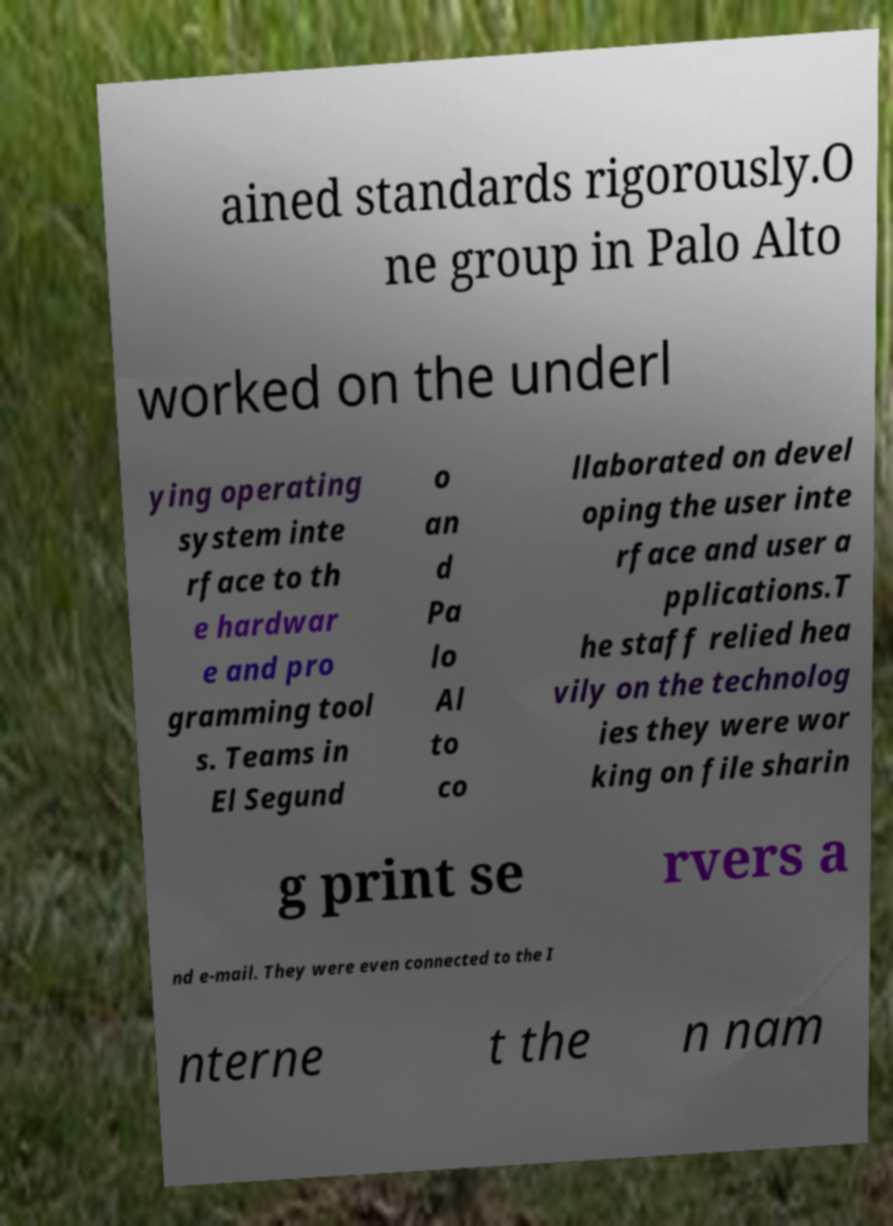I need the written content from this picture converted into text. Can you do that? ained standards rigorously.O ne group in Palo Alto worked on the underl ying operating system inte rface to th e hardwar e and pro gramming tool s. Teams in El Segund o an d Pa lo Al to co llaborated on devel oping the user inte rface and user a pplications.T he staff relied hea vily on the technolog ies they were wor king on file sharin g print se rvers a nd e-mail. They were even connected to the I nterne t the n nam 